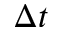<formula> <loc_0><loc_0><loc_500><loc_500>\Delta t</formula> 